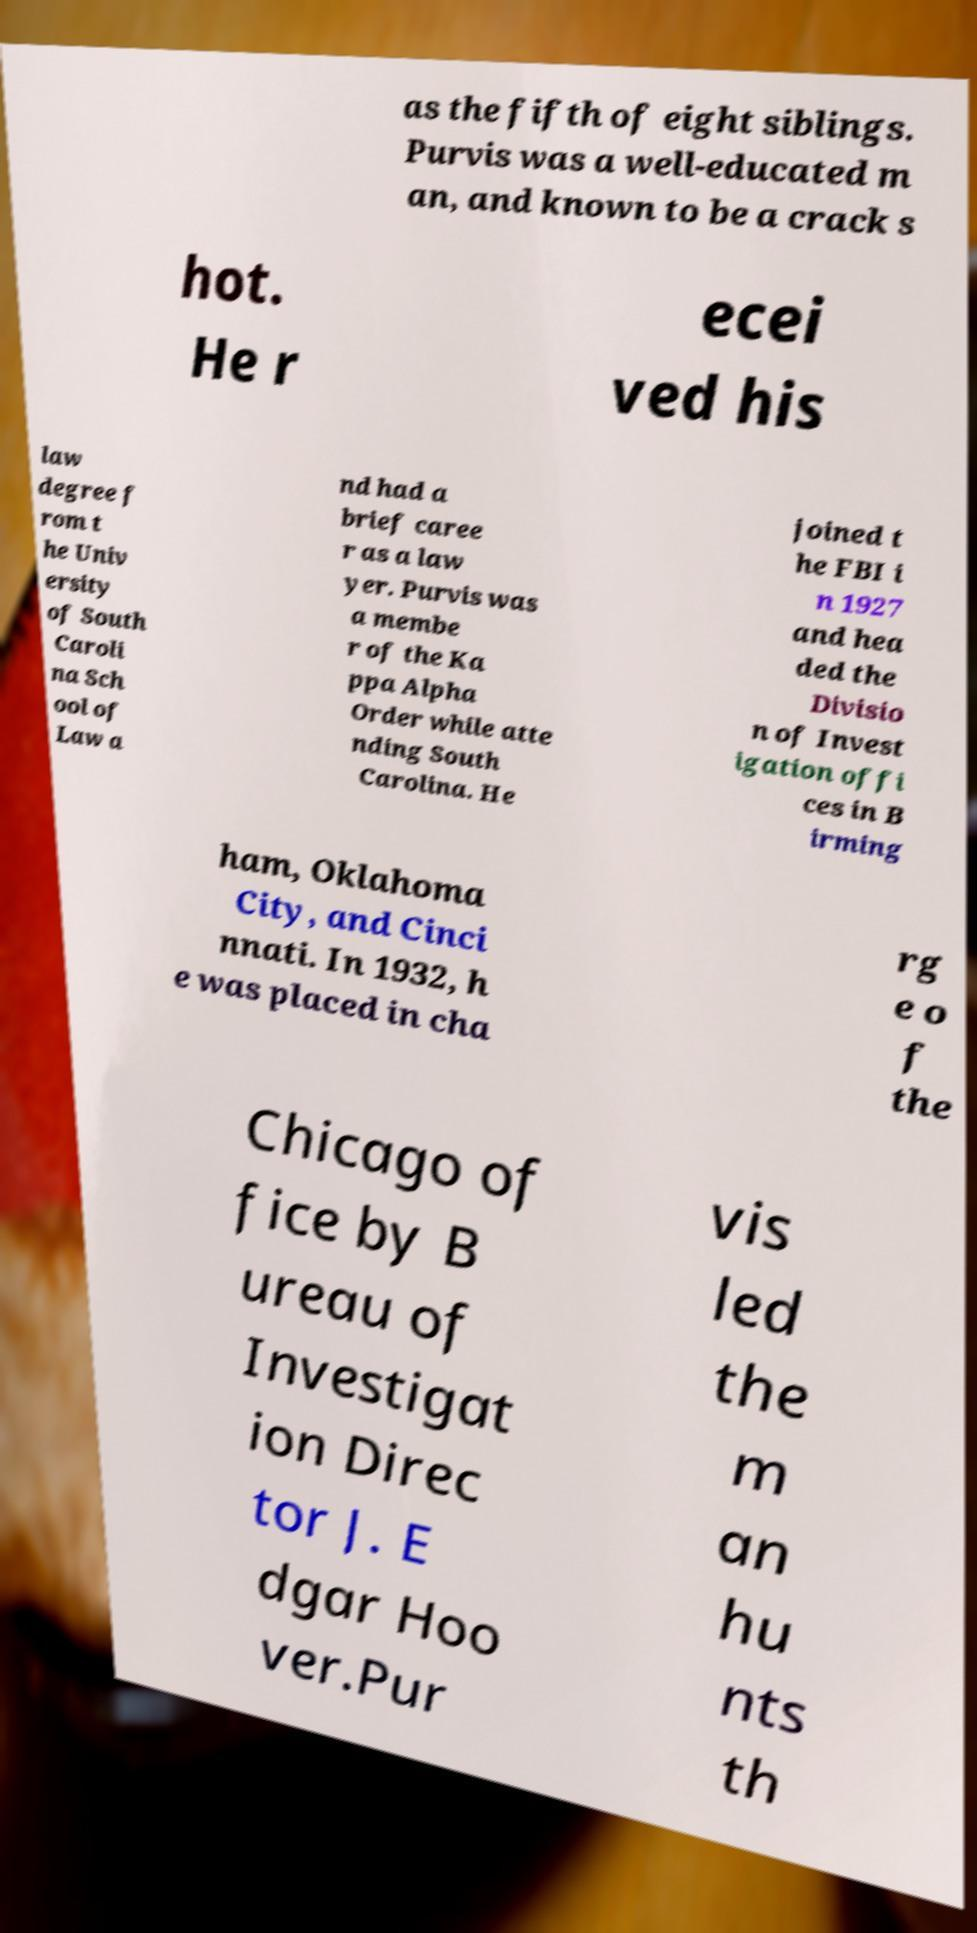Could you extract and type out the text from this image? as the fifth of eight siblings. Purvis was a well-educated m an, and known to be a crack s hot. He r ecei ved his law degree f rom t he Univ ersity of South Caroli na Sch ool of Law a nd had a brief caree r as a law yer. Purvis was a membe r of the Ka ppa Alpha Order while atte nding South Carolina. He joined t he FBI i n 1927 and hea ded the Divisio n of Invest igation offi ces in B irming ham, Oklahoma City, and Cinci nnati. In 1932, h e was placed in cha rg e o f the Chicago of fice by B ureau of Investigat ion Direc tor J. E dgar Hoo ver.Pur vis led the m an hu nts th 